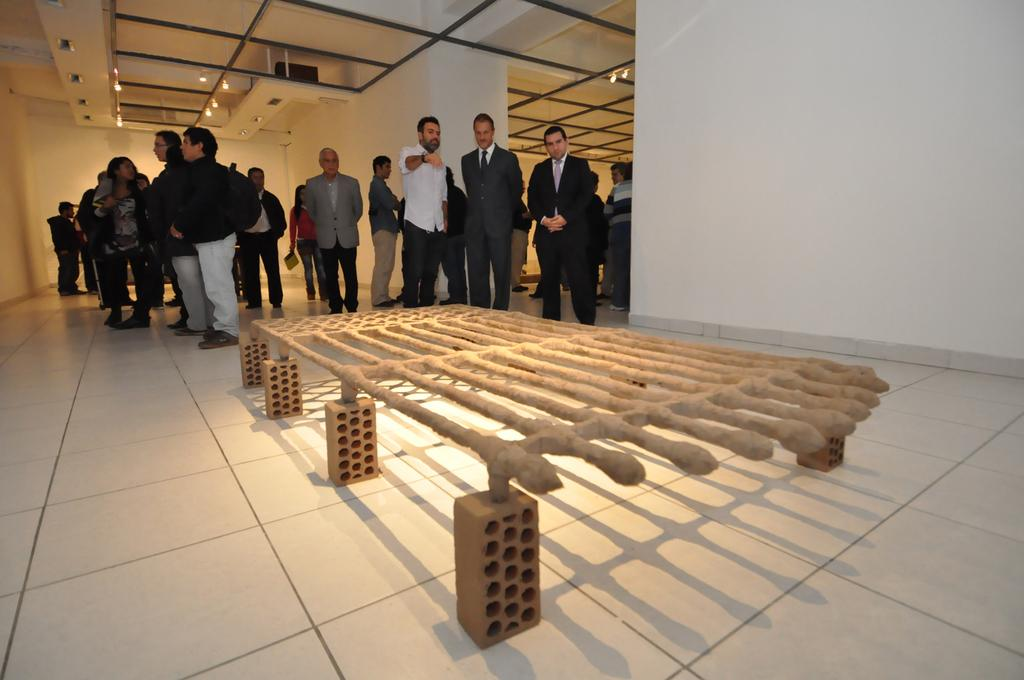How many persons can be seen standing in the image? There are few persons standing in the image. What is the object in front of the persons in the image? Unfortunately, the provided facts do not specify the nature of the object in front of the persons. What type of street is visible in the image? There is no street visible in the image; it only shows a few persons standing with an object in front of them. What religious symbols can be seen in the image? There is no mention of any religious symbols in the provided facts, so we cannot determine their presence in the image. 